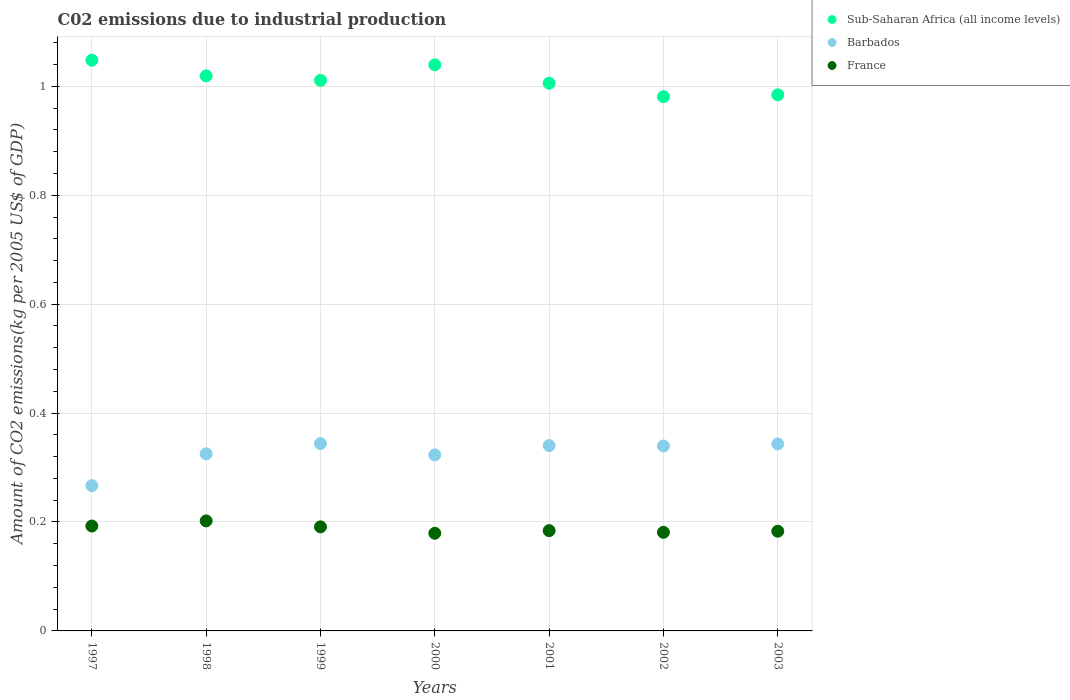What is the amount of CO2 emitted due to industrial production in Sub-Saharan Africa (all income levels) in 1997?
Make the answer very short. 1.05. Across all years, what is the maximum amount of CO2 emitted due to industrial production in Barbados?
Make the answer very short. 0.34. Across all years, what is the minimum amount of CO2 emitted due to industrial production in France?
Provide a succinct answer. 0.18. What is the total amount of CO2 emitted due to industrial production in Barbados in the graph?
Ensure brevity in your answer.  2.28. What is the difference between the amount of CO2 emitted due to industrial production in France in 2000 and that in 2003?
Make the answer very short. -0. What is the difference between the amount of CO2 emitted due to industrial production in Barbados in 1998 and the amount of CO2 emitted due to industrial production in Sub-Saharan Africa (all income levels) in 2000?
Provide a short and direct response. -0.71. What is the average amount of CO2 emitted due to industrial production in Sub-Saharan Africa (all income levels) per year?
Offer a terse response. 1.01. In the year 1999, what is the difference between the amount of CO2 emitted due to industrial production in Barbados and amount of CO2 emitted due to industrial production in Sub-Saharan Africa (all income levels)?
Give a very brief answer. -0.67. What is the ratio of the amount of CO2 emitted due to industrial production in Sub-Saharan Africa (all income levels) in 2000 to that in 2002?
Offer a very short reply. 1.06. What is the difference between the highest and the second highest amount of CO2 emitted due to industrial production in France?
Provide a succinct answer. 0.01. What is the difference between the highest and the lowest amount of CO2 emitted due to industrial production in France?
Give a very brief answer. 0.02. Is the amount of CO2 emitted due to industrial production in Barbados strictly greater than the amount of CO2 emitted due to industrial production in Sub-Saharan Africa (all income levels) over the years?
Your answer should be very brief. No. How many dotlines are there?
Offer a terse response. 3. How many years are there in the graph?
Keep it short and to the point. 7. Are the values on the major ticks of Y-axis written in scientific E-notation?
Provide a succinct answer. No. Does the graph contain grids?
Offer a very short reply. Yes. How many legend labels are there?
Make the answer very short. 3. How are the legend labels stacked?
Provide a short and direct response. Vertical. What is the title of the graph?
Offer a terse response. C02 emissions due to industrial production. Does "Namibia" appear as one of the legend labels in the graph?
Provide a short and direct response. No. What is the label or title of the Y-axis?
Your response must be concise. Amount of CO2 emissions(kg per 2005 US$ of GDP). What is the Amount of CO2 emissions(kg per 2005 US$ of GDP) in Sub-Saharan Africa (all income levels) in 1997?
Offer a terse response. 1.05. What is the Amount of CO2 emissions(kg per 2005 US$ of GDP) in Barbados in 1997?
Provide a short and direct response. 0.27. What is the Amount of CO2 emissions(kg per 2005 US$ of GDP) of France in 1997?
Provide a succinct answer. 0.19. What is the Amount of CO2 emissions(kg per 2005 US$ of GDP) of Sub-Saharan Africa (all income levels) in 1998?
Your response must be concise. 1.02. What is the Amount of CO2 emissions(kg per 2005 US$ of GDP) in Barbados in 1998?
Offer a terse response. 0.33. What is the Amount of CO2 emissions(kg per 2005 US$ of GDP) in France in 1998?
Offer a terse response. 0.2. What is the Amount of CO2 emissions(kg per 2005 US$ of GDP) of Sub-Saharan Africa (all income levels) in 1999?
Give a very brief answer. 1.01. What is the Amount of CO2 emissions(kg per 2005 US$ of GDP) of Barbados in 1999?
Your answer should be very brief. 0.34. What is the Amount of CO2 emissions(kg per 2005 US$ of GDP) of France in 1999?
Provide a short and direct response. 0.19. What is the Amount of CO2 emissions(kg per 2005 US$ of GDP) in Sub-Saharan Africa (all income levels) in 2000?
Give a very brief answer. 1.04. What is the Amount of CO2 emissions(kg per 2005 US$ of GDP) in Barbados in 2000?
Offer a terse response. 0.32. What is the Amount of CO2 emissions(kg per 2005 US$ of GDP) of France in 2000?
Ensure brevity in your answer.  0.18. What is the Amount of CO2 emissions(kg per 2005 US$ of GDP) of Sub-Saharan Africa (all income levels) in 2001?
Offer a terse response. 1.01. What is the Amount of CO2 emissions(kg per 2005 US$ of GDP) of Barbados in 2001?
Give a very brief answer. 0.34. What is the Amount of CO2 emissions(kg per 2005 US$ of GDP) of France in 2001?
Ensure brevity in your answer.  0.18. What is the Amount of CO2 emissions(kg per 2005 US$ of GDP) of Sub-Saharan Africa (all income levels) in 2002?
Your answer should be compact. 0.98. What is the Amount of CO2 emissions(kg per 2005 US$ of GDP) in Barbados in 2002?
Offer a terse response. 0.34. What is the Amount of CO2 emissions(kg per 2005 US$ of GDP) of France in 2002?
Offer a terse response. 0.18. What is the Amount of CO2 emissions(kg per 2005 US$ of GDP) of Sub-Saharan Africa (all income levels) in 2003?
Offer a terse response. 0.98. What is the Amount of CO2 emissions(kg per 2005 US$ of GDP) in Barbados in 2003?
Your answer should be very brief. 0.34. What is the Amount of CO2 emissions(kg per 2005 US$ of GDP) in France in 2003?
Provide a short and direct response. 0.18. Across all years, what is the maximum Amount of CO2 emissions(kg per 2005 US$ of GDP) of Sub-Saharan Africa (all income levels)?
Offer a terse response. 1.05. Across all years, what is the maximum Amount of CO2 emissions(kg per 2005 US$ of GDP) of Barbados?
Provide a short and direct response. 0.34. Across all years, what is the maximum Amount of CO2 emissions(kg per 2005 US$ of GDP) in France?
Provide a short and direct response. 0.2. Across all years, what is the minimum Amount of CO2 emissions(kg per 2005 US$ of GDP) in Sub-Saharan Africa (all income levels)?
Offer a terse response. 0.98. Across all years, what is the minimum Amount of CO2 emissions(kg per 2005 US$ of GDP) in Barbados?
Keep it short and to the point. 0.27. Across all years, what is the minimum Amount of CO2 emissions(kg per 2005 US$ of GDP) in France?
Offer a terse response. 0.18. What is the total Amount of CO2 emissions(kg per 2005 US$ of GDP) in Sub-Saharan Africa (all income levels) in the graph?
Provide a succinct answer. 7.09. What is the total Amount of CO2 emissions(kg per 2005 US$ of GDP) of Barbados in the graph?
Your answer should be very brief. 2.28. What is the total Amount of CO2 emissions(kg per 2005 US$ of GDP) of France in the graph?
Your answer should be compact. 1.31. What is the difference between the Amount of CO2 emissions(kg per 2005 US$ of GDP) in Sub-Saharan Africa (all income levels) in 1997 and that in 1998?
Ensure brevity in your answer.  0.03. What is the difference between the Amount of CO2 emissions(kg per 2005 US$ of GDP) of Barbados in 1997 and that in 1998?
Provide a succinct answer. -0.06. What is the difference between the Amount of CO2 emissions(kg per 2005 US$ of GDP) in France in 1997 and that in 1998?
Give a very brief answer. -0.01. What is the difference between the Amount of CO2 emissions(kg per 2005 US$ of GDP) of Sub-Saharan Africa (all income levels) in 1997 and that in 1999?
Give a very brief answer. 0.04. What is the difference between the Amount of CO2 emissions(kg per 2005 US$ of GDP) in Barbados in 1997 and that in 1999?
Ensure brevity in your answer.  -0.08. What is the difference between the Amount of CO2 emissions(kg per 2005 US$ of GDP) in France in 1997 and that in 1999?
Make the answer very short. 0. What is the difference between the Amount of CO2 emissions(kg per 2005 US$ of GDP) in Sub-Saharan Africa (all income levels) in 1997 and that in 2000?
Offer a very short reply. 0.01. What is the difference between the Amount of CO2 emissions(kg per 2005 US$ of GDP) of Barbados in 1997 and that in 2000?
Keep it short and to the point. -0.06. What is the difference between the Amount of CO2 emissions(kg per 2005 US$ of GDP) of France in 1997 and that in 2000?
Provide a succinct answer. 0.01. What is the difference between the Amount of CO2 emissions(kg per 2005 US$ of GDP) in Sub-Saharan Africa (all income levels) in 1997 and that in 2001?
Offer a terse response. 0.04. What is the difference between the Amount of CO2 emissions(kg per 2005 US$ of GDP) in Barbados in 1997 and that in 2001?
Provide a short and direct response. -0.07. What is the difference between the Amount of CO2 emissions(kg per 2005 US$ of GDP) of France in 1997 and that in 2001?
Offer a very short reply. 0.01. What is the difference between the Amount of CO2 emissions(kg per 2005 US$ of GDP) of Sub-Saharan Africa (all income levels) in 1997 and that in 2002?
Your answer should be very brief. 0.07. What is the difference between the Amount of CO2 emissions(kg per 2005 US$ of GDP) in Barbados in 1997 and that in 2002?
Give a very brief answer. -0.07. What is the difference between the Amount of CO2 emissions(kg per 2005 US$ of GDP) in France in 1997 and that in 2002?
Offer a terse response. 0.01. What is the difference between the Amount of CO2 emissions(kg per 2005 US$ of GDP) in Sub-Saharan Africa (all income levels) in 1997 and that in 2003?
Give a very brief answer. 0.06. What is the difference between the Amount of CO2 emissions(kg per 2005 US$ of GDP) of Barbados in 1997 and that in 2003?
Your answer should be compact. -0.08. What is the difference between the Amount of CO2 emissions(kg per 2005 US$ of GDP) of France in 1997 and that in 2003?
Your answer should be compact. 0.01. What is the difference between the Amount of CO2 emissions(kg per 2005 US$ of GDP) of Sub-Saharan Africa (all income levels) in 1998 and that in 1999?
Give a very brief answer. 0.01. What is the difference between the Amount of CO2 emissions(kg per 2005 US$ of GDP) in Barbados in 1998 and that in 1999?
Your response must be concise. -0.02. What is the difference between the Amount of CO2 emissions(kg per 2005 US$ of GDP) of France in 1998 and that in 1999?
Offer a very short reply. 0.01. What is the difference between the Amount of CO2 emissions(kg per 2005 US$ of GDP) in Sub-Saharan Africa (all income levels) in 1998 and that in 2000?
Provide a short and direct response. -0.02. What is the difference between the Amount of CO2 emissions(kg per 2005 US$ of GDP) in Barbados in 1998 and that in 2000?
Offer a terse response. 0. What is the difference between the Amount of CO2 emissions(kg per 2005 US$ of GDP) of France in 1998 and that in 2000?
Keep it short and to the point. 0.02. What is the difference between the Amount of CO2 emissions(kg per 2005 US$ of GDP) in Sub-Saharan Africa (all income levels) in 1998 and that in 2001?
Offer a very short reply. 0.01. What is the difference between the Amount of CO2 emissions(kg per 2005 US$ of GDP) in Barbados in 1998 and that in 2001?
Give a very brief answer. -0.02. What is the difference between the Amount of CO2 emissions(kg per 2005 US$ of GDP) in France in 1998 and that in 2001?
Your answer should be very brief. 0.02. What is the difference between the Amount of CO2 emissions(kg per 2005 US$ of GDP) in Sub-Saharan Africa (all income levels) in 1998 and that in 2002?
Offer a terse response. 0.04. What is the difference between the Amount of CO2 emissions(kg per 2005 US$ of GDP) in Barbados in 1998 and that in 2002?
Ensure brevity in your answer.  -0.01. What is the difference between the Amount of CO2 emissions(kg per 2005 US$ of GDP) in France in 1998 and that in 2002?
Provide a short and direct response. 0.02. What is the difference between the Amount of CO2 emissions(kg per 2005 US$ of GDP) of Sub-Saharan Africa (all income levels) in 1998 and that in 2003?
Ensure brevity in your answer.  0.03. What is the difference between the Amount of CO2 emissions(kg per 2005 US$ of GDP) of Barbados in 1998 and that in 2003?
Give a very brief answer. -0.02. What is the difference between the Amount of CO2 emissions(kg per 2005 US$ of GDP) in France in 1998 and that in 2003?
Give a very brief answer. 0.02. What is the difference between the Amount of CO2 emissions(kg per 2005 US$ of GDP) of Sub-Saharan Africa (all income levels) in 1999 and that in 2000?
Ensure brevity in your answer.  -0.03. What is the difference between the Amount of CO2 emissions(kg per 2005 US$ of GDP) in Barbados in 1999 and that in 2000?
Your answer should be very brief. 0.02. What is the difference between the Amount of CO2 emissions(kg per 2005 US$ of GDP) of France in 1999 and that in 2000?
Make the answer very short. 0.01. What is the difference between the Amount of CO2 emissions(kg per 2005 US$ of GDP) in Sub-Saharan Africa (all income levels) in 1999 and that in 2001?
Provide a short and direct response. 0.01. What is the difference between the Amount of CO2 emissions(kg per 2005 US$ of GDP) of Barbados in 1999 and that in 2001?
Keep it short and to the point. 0. What is the difference between the Amount of CO2 emissions(kg per 2005 US$ of GDP) of France in 1999 and that in 2001?
Offer a terse response. 0.01. What is the difference between the Amount of CO2 emissions(kg per 2005 US$ of GDP) in Sub-Saharan Africa (all income levels) in 1999 and that in 2002?
Provide a short and direct response. 0.03. What is the difference between the Amount of CO2 emissions(kg per 2005 US$ of GDP) in Barbados in 1999 and that in 2002?
Provide a short and direct response. 0. What is the difference between the Amount of CO2 emissions(kg per 2005 US$ of GDP) in Sub-Saharan Africa (all income levels) in 1999 and that in 2003?
Your answer should be compact. 0.03. What is the difference between the Amount of CO2 emissions(kg per 2005 US$ of GDP) in Barbados in 1999 and that in 2003?
Keep it short and to the point. 0. What is the difference between the Amount of CO2 emissions(kg per 2005 US$ of GDP) in France in 1999 and that in 2003?
Your answer should be very brief. 0.01. What is the difference between the Amount of CO2 emissions(kg per 2005 US$ of GDP) in Sub-Saharan Africa (all income levels) in 2000 and that in 2001?
Ensure brevity in your answer.  0.03. What is the difference between the Amount of CO2 emissions(kg per 2005 US$ of GDP) of Barbados in 2000 and that in 2001?
Your response must be concise. -0.02. What is the difference between the Amount of CO2 emissions(kg per 2005 US$ of GDP) of France in 2000 and that in 2001?
Give a very brief answer. -0. What is the difference between the Amount of CO2 emissions(kg per 2005 US$ of GDP) in Sub-Saharan Africa (all income levels) in 2000 and that in 2002?
Your response must be concise. 0.06. What is the difference between the Amount of CO2 emissions(kg per 2005 US$ of GDP) of Barbados in 2000 and that in 2002?
Provide a short and direct response. -0.02. What is the difference between the Amount of CO2 emissions(kg per 2005 US$ of GDP) of France in 2000 and that in 2002?
Your answer should be very brief. -0. What is the difference between the Amount of CO2 emissions(kg per 2005 US$ of GDP) in Sub-Saharan Africa (all income levels) in 2000 and that in 2003?
Make the answer very short. 0.06. What is the difference between the Amount of CO2 emissions(kg per 2005 US$ of GDP) of Barbados in 2000 and that in 2003?
Your answer should be very brief. -0.02. What is the difference between the Amount of CO2 emissions(kg per 2005 US$ of GDP) of France in 2000 and that in 2003?
Provide a short and direct response. -0. What is the difference between the Amount of CO2 emissions(kg per 2005 US$ of GDP) of Sub-Saharan Africa (all income levels) in 2001 and that in 2002?
Offer a very short reply. 0.02. What is the difference between the Amount of CO2 emissions(kg per 2005 US$ of GDP) in Barbados in 2001 and that in 2002?
Your response must be concise. 0. What is the difference between the Amount of CO2 emissions(kg per 2005 US$ of GDP) in France in 2001 and that in 2002?
Offer a very short reply. 0. What is the difference between the Amount of CO2 emissions(kg per 2005 US$ of GDP) in Sub-Saharan Africa (all income levels) in 2001 and that in 2003?
Provide a short and direct response. 0.02. What is the difference between the Amount of CO2 emissions(kg per 2005 US$ of GDP) in Barbados in 2001 and that in 2003?
Provide a succinct answer. -0. What is the difference between the Amount of CO2 emissions(kg per 2005 US$ of GDP) in France in 2001 and that in 2003?
Your response must be concise. 0. What is the difference between the Amount of CO2 emissions(kg per 2005 US$ of GDP) in Sub-Saharan Africa (all income levels) in 2002 and that in 2003?
Make the answer very short. -0. What is the difference between the Amount of CO2 emissions(kg per 2005 US$ of GDP) in Barbados in 2002 and that in 2003?
Your response must be concise. -0. What is the difference between the Amount of CO2 emissions(kg per 2005 US$ of GDP) of France in 2002 and that in 2003?
Provide a short and direct response. -0. What is the difference between the Amount of CO2 emissions(kg per 2005 US$ of GDP) in Sub-Saharan Africa (all income levels) in 1997 and the Amount of CO2 emissions(kg per 2005 US$ of GDP) in Barbados in 1998?
Your answer should be compact. 0.72. What is the difference between the Amount of CO2 emissions(kg per 2005 US$ of GDP) in Sub-Saharan Africa (all income levels) in 1997 and the Amount of CO2 emissions(kg per 2005 US$ of GDP) in France in 1998?
Ensure brevity in your answer.  0.85. What is the difference between the Amount of CO2 emissions(kg per 2005 US$ of GDP) in Barbados in 1997 and the Amount of CO2 emissions(kg per 2005 US$ of GDP) in France in 1998?
Provide a succinct answer. 0.06. What is the difference between the Amount of CO2 emissions(kg per 2005 US$ of GDP) in Sub-Saharan Africa (all income levels) in 1997 and the Amount of CO2 emissions(kg per 2005 US$ of GDP) in Barbados in 1999?
Give a very brief answer. 0.7. What is the difference between the Amount of CO2 emissions(kg per 2005 US$ of GDP) in Sub-Saharan Africa (all income levels) in 1997 and the Amount of CO2 emissions(kg per 2005 US$ of GDP) in France in 1999?
Your answer should be compact. 0.86. What is the difference between the Amount of CO2 emissions(kg per 2005 US$ of GDP) of Barbados in 1997 and the Amount of CO2 emissions(kg per 2005 US$ of GDP) of France in 1999?
Provide a short and direct response. 0.08. What is the difference between the Amount of CO2 emissions(kg per 2005 US$ of GDP) in Sub-Saharan Africa (all income levels) in 1997 and the Amount of CO2 emissions(kg per 2005 US$ of GDP) in Barbados in 2000?
Provide a short and direct response. 0.72. What is the difference between the Amount of CO2 emissions(kg per 2005 US$ of GDP) of Sub-Saharan Africa (all income levels) in 1997 and the Amount of CO2 emissions(kg per 2005 US$ of GDP) of France in 2000?
Offer a terse response. 0.87. What is the difference between the Amount of CO2 emissions(kg per 2005 US$ of GDP) of Barbados in 1997 and the Amount of CO2 emissions(kg per 2005 US$ of GDP) of France in 2000?
Provide a succinct answer. 0.09. What is the difference between the Amount of CO2 emissions(kg per 2005 US$ of GDP) in Sub-Saharan Africa (all income levels) in 1997 and the Amount of CO2 emissions(kg per 2005 US$ of GDP) in Barbados in 2001?
Provide a succinct answer. 0.71. What is the difference between the Amount of CO2 emissions(kg per 2005 US$ of GDP) of Sub-Saharan Africa (all income levels) in 1997 and the Amount of CO2 emissions(kg per 2005 US$ of GDP) of France in 2001?
Offer a terse response. 0.86. What is the difference between the Amount of CO2 emissions(kg per 2005 US$ of GDP) of Barbados in 1997 and the Amount of CO2 emissions(kg per 2005 US$ of GDP) of France in 2001?
Provide a short and direct response. 0.08. What is the difference between the Amount of CO2 emissions(kg per 2005 US$ of GDP) in Sub-Saharan Africa (all income levels) in 1997 and the Amount of CO2 emissions(kg per 2005 US$ of GDP) in Barbados in 2002?
Offer a terse response. 0.71. What is the difference between the Amount of CO2 emissions(kg per 2005 US$ of GDP) in Sub-Saharan Africa (all income levels) in 1997 and the Amount of CO2 emissions(kg per 2005 US$ of GDP) in France in 2002?
Your answer should be very brief. 0.87. What is the difference between the Amount of CO2 emissions(kg per 2005 US$ of GDP) in Barbados in 1997 and the Amount of CO2 emissions(kg per 2005 US$ of GDP) in France in 2002?
Your response must be concise. 0.09. What is the difference between the Amount of CO2 emissions(kg per 2005 US$ of GDP) in Sub-Saharan Africa (all income levels) in 1997 and the Amount of CO2 emissions(kg per 2005 US$ of GDP) in Barbados in 2003?
Provide a succinct answer. 0.7. What is the difference between the Amount of CO2 emissions(kg per 2005 US$ of GDP) in Sub-Saharan Africa (all income levels) in 1997 and the Amount of CO2 emissions(kg per 2005 US$ of GDP) in France in 2003?
Provide a succinct answer. 0.86. What is the difference between the Amount of CO2 emissions(kg per 2005 US$ of GDP) in Barbados in 1997 and the Amount of CO2 emissions(kg per 2005 US$ of GDP) in France in 2003?
Make the answer very short. 0.08. What is the difference between the Amount of CO2 emissions(kg per 2005 US$ of GDP) of Sub-Saharan Africa (all income levels) in 1998 and the Amount of CO2 emissions(kg per 2005 US$ of GDP) of Barbados in 1999?
Your answer should be compact. 0.68. What is the difference between the Amount of CO2 emissions(kg per 2005 US$ of GDP) of Sub-Saharan Africa (all income levels) in 1998 and the Amount of CO2 emissions(kg per 2005 US$ of GDP) of France in 1999?
Your answer should be very brief. 0.83. What is the difference between the Amount of CO2 emissions(kg per 2005 US$ of GDP) of Barbados in 1998 and the Amount of CO2 emissions(kg per 2005 US$ of GDP) of France in 1999?
Provide a succinct answer. 0.13. What is the difference between the Amount of CO2 emissions(kg per 2005 US$ of GDP) in Sub-Saharan Africa (all income levels) in 1998 and the Amount of CO2 emissions(kg per 2005 US$ of GDP) in Barbados in 2000?
Your answer should be compact. 0.7. What is the difference between the Amount of CO2 emissions(kg per 2005 US$ of GDP) of Sub-Saharan Africa (all income levels) in 1998 and the Amount of CO2 emissions(kg per 2005 US$ of GDP) of France in 2000?
Provide a succinct answer. 0.84. What is the difference between the Amount of CO2 emissions(kg per 2005 US$ of GDP) in Barbados in 1998 and the Amount of CO2 emissions(kg per 2005 US$ of GDP) in France in 2000?
Provide a succinct answer. 0.15. What is the difference between the Amount of CO2 emissions(kg per 2005 US$ of GDP) of Sub-Saharan Africa (all income levels) in 1998 and the Amount of CO2 emissions(kg per 2005 US$ of GDP) of Barbados in 2001?
Make the answer very short. 0.68. What is the difference between the Amount of CO2 emissions(kg per 2005 US$ of GDP) of Sub-Saharan Africa (all income levels) in 1998 and the Amount of CO2 emissions(kg per 2005 US$ of GDP) of France in 2001?
Your response must be concise. 0.83. What is the difference between the Amount of CO2 emissions(kg per 2005 US$ of GDP) of Barbados in 1998 and the Amount of CO2 emissions(kg per 2005 US$ of GDP) of France in 2001?
Your response must be concise. 0.14. What is the difference between the Amount of CO2 emissions(kg per 2005 US$ of GDP) of Sub-Saharan Africa (all income levels) in 1998 and the Amount of CO2 emissions(kg per 2005 US$ of GDP) of Barbados in 2002?
Your answer should be very brief. 0.68. What is the difference between the Amount of CO2 emissions(kg per 2005 US$ of GDP) of Sub-Saharan Africa (all income levels) in 1998 and the Amount of CO2 emissions(kg per 2005 US$ of GDP) of France in 2002?
Your answer should be compact. 0.84. What is the difference between the Amount of CO2 emissions(kg per 2005 US$ of GDP) in Barbados in 1998 and the Amount of CO2 emissions(kg per 2005 US$ of GDP) in France in 2002?
Provide a short and direct response. 0.14. What is the difference between the Amount of CO2 emissions(kg per 2005 US$ of GDP) in Sub-Saharan Africa (all income levels) in 1998 and the Amount of CO2 emissions(kg per 2005 US$ of GDP) in Barbados in 2003?
Provide a short and direct response. 0.68. What is the difference between the Amount of CO2 emissions(kg per 2005 US$ of GDP) in Sub-Saharan Africa (all income levels) in 1998 and the Amount of CO2 emissions(kg per 2005 US$ of GDP) in France in 2003?
Your answer should be compact. 0.84. What is the difference between the Amount of CO2 emissions(kg per 2005 US$ of GDP) in Barbados in 1998 and the Amount of CO2 emissions(kg per 2005 US$ of GDP) in France in 2003?
Provide a succinct answer. 0.14. What is the difference between the Amount of CO2 emissions(kg per 2005 US$ of GDP) of Sub-Saharan Africa (all income levels) in 1999 and the Amount of CO2 emissions(kg per 2005 US$ of GDP) of Barbados in 2000?
Provide a succinct answer. 0.69. What is the difference between the Amount of CO2 emissions(kg per 2005 US$ of GDP) in Sub-Saharan Africa (all income levels) in 1999 and the Amount of CO2 emissions(kg per 2005 US$ of GDP) in France in 2000?
Offer a terse response. 0.83. What is the difference between the Amount of CO2 emissions(kg per 2005 US$ of GDP) in Barbados in 1999 and the Amount of CO2 emissions(kg per 2005 US$ of GDP) in France in 2000?
Provide a succinct answer. 0.16. What is the difference between the Amount of CO2 emissions(kg per 2005 US$ of GDP) in Sub-Saharan Africa (all income levels) in 1999 and the Amount of CO2 emissions(kg per 2005 US$ of GDP) in Barbados in 2001?
Your answer should be compact. 0.67. What is the difference between the Amount of CO2 emissions(kg per 2005 US$ of GDP) of Sub-Saharan Africa (all income levels) in 1999 and the Amount of CO2 emissions(kg per 2005 US$ of GDP) of France in 2001?
Give a very brief answer. 0.83. What is the difference between the Amount of CO2 emissions(kg per 2005 US$ of GDP) of Barbados in 1999 and the Amount of CO2 emissions(kg per 2005 US$ of GDP) of France in 2001?
Provide a short and direct response. 0.16. What is the difference between the Amount of CO2 emissions(kg per 2005 US$ of GDP) of Sub-Saharan Africa (all income levels) in 1999 and the Amount of CO2 emissions(kg per 2005 US$ of GDP) of Barbados in 2002?
Offer a terse response. 0.67. What is the difference between the Amount of CO2 emissions(kg per 2005 US$ of GDP) in Sub-Saharan Africa (all income levels) in 1999 and the Amount of CO2 emissions(kg per 2005 US$ of GDP) in France in 2002?
Keep it short and to the point. 0.83. What is the difference between the Amount of CO2 emissions(kg per 2005 US$ of GDP) in Barbados in 1999 and the Amount of CO2 emissions(kg per 2005 US$ of GDP) in France in 2002?
Keep it short and to the point. 0.16. What is the difference between the Amount of CO2 emissions(kg per 2005 US$ of GDP) in Sub-Saharan Africa (all income levels) in 1999 and the Amount of CO2 emissions(kg per 2005 US$ of GDP) in Barbados in 2003?
Give a very brief answer. 0.67. What is the difference between the Amount of CO2 emissions(kg per 2005 US$ of GDP) in Sub-Saharan Africa (all income levels) in 1999 and the Amount of CO2 emissions(kg per 2005 US$ of GDP) in France in 2003?
Offer a terse response. 0.83. What is the difference between the Amount of CO2 emissions(kg per 2005 US$ of GDP) in Barbados in 1999 and the Amount of CO2 emissions(kg per 2005 US$ of GDP) in France in 2003?
Make the answer very short. 0.16. What is the difference between the Amount of CO2 emissions(kg per 2005 US$ of GDP) in Sub-Saharan Africa (all income levels) in 2000 and the Amount of CO2 emissions(kg per 2005 US$ of GDP) in Barbados in 2001?
Offer a terse response. 0.7. What is the difference between the Amount of CO2 emissions(kg per 2005 US$ of GDP) in Sub-Saharan Africa (all income levels) in 2000 and the Amount of CO2 emissions(kg per 2005 US$ of GDP) in France in 2001?
Provide a succinct answer. 0.86. What is the difference between the Amount of CO2 emissions(kg per 2005 US$ of GDP) in Barbados in 2000 and the Amount of CO2 emissions(kg per 2005 US$ of GDP) in France in 2001?
Offer a terse response. 0.14. What is the difference between the Amount of CO2 emissions(kg per 2005 US$ of GDP) in Sub-Saharan Africa (all income levels) in 2000 and the Amount of CO2 emissions(kg per 2005 US$ of GDP) in Barbados in 2002?
Ensure brevity in your answer.  0.7. What is the difference between the Amount of CO2 emissions(kg per 2005 US$ of GDP) of Sub-Saharan Africa (all income levels) in 2000 and the Amount of CO2 emissions(kg per 2005 US$ of GDP) of France in 2002?
Offer a very short reply. 0.86. What is the difference between the Amount of CO2 emissions(kg per 2005 US$ of GDP) of Barbados in 2000 and the Amount of CO2 emissions(kg per 2005 US$ of GDP) of France in 2002?
Make the answer very short. 0.14. What is the difference between the Amount of CO2 emissions(kg per 2005 US$ of GDP) in Sub-Saharan Africa (all income levels) in 2000 and the Amount of CO2 emissions(kg per 2005 US$ of GDP) in Barbados in 2003?
Ensure brevity in your answer.  0.7. What is the difference between the Amount of CO2 emissions(kg per 2005 US$ of GDP) of Sub-Saharan Africa (all income levels) in 2000 and the Amount of CO2 emissions(kg per 2005 US$ of GDP) of France in 2003?
Your response must be concise. 0.86. What is the difference between the Amount of CO2 emissions(kg per 2005 US$ of GDP) of Barbados in 2000 and the Amount of CO2 emissions(kg per 2005 US$ of GDP) of France in 2003?
Ensure brevity in your answer.  0.14. What is the difference between the Amount of CO2 emissions(kg per 2005 US$ of GDP) of Sub-Saharan Africa (all income levels) in 2001 and the Amount of CO2 emissions(kg per 2005 US$ of GDP) of Barbados in 2002?
Your answer should be very brief. 0.67. What is the difference between the Amount of CO2 emissions(kg per 2005 US$ of GDP) of Sub-Saharan Africa (all income levels) in 2001 and the Amount of CO2 emissions(kg per 2005 US$ of GDP) of France in 2002?
Provide a succinct answer. 0.82. What is the difference between the Amount of CO2 emissions(kg per 2005 US$ of GDP) of Barbados in 2001 and the Amount of CO2 emissions(kg per 2005 US$ of GDP) of France in 2002?
Ensure brevity in your answer.  0.16. What is the difference between the Amount of CO2 emissions(kg per 2005 US$ of GDP) of Sub-Saharan Africa (all income levels) in 2001 and the Amount of CO2 emissions(kg per 2005 US$ of GDP) of Barbados in 2003?
Your answer should be very brief. 0.66. What is the difference between the Amount of CO2 emissions(kg per 2005 US$ of GDP) in Sub-Saharan Africa (all income levels) in 2001 and the Amount of CO2 emissions(kg per 2005 US$ of GDP) in France in 2003?
Offer a terse response. 0.82. What is the difference between the Amount of CO2 emissions(kg per 2005 US$ of GDP) of Barbados in 2001 and the Amount of CO2 emissions(kg per 2005 US$ of GDP) of France in 2003?
Your answer should be compact. 0.16. What is the difference between the Amount of CO2 emissions(kg per 2005 US$ of GDP) of Sub-Saharan Africa (all income levels) in 2002 and the Amount of CO2 emissions(kg per 2005 US$ of GDP) of Barbados in 2003?
Offer a terse response. 0.64. What is the difference between the Amount of CO2 emissions(kg per 2005 US$ of GDP) in Sub-Saharan Africa (all income levels) in 2002 and the Amount of CO2 emissions(kg per 2005 US$ of GDP) in France in 2003?
Keep it short and to the point. 0.8. What is the difference between the Amount of CO2 emissions(kg per 2005 US$ of GDP) of Barbados in 2002 and the Amount of CO2 emissions(kg per 2005 US$ of GDP) of France in 2003?
Your response must be concise. 0.16. What is the average Amount of CO2 emissions(kg per 2005 US$ of GDP) in Sub-Saharan Africa (all income levels) per year?
Ensure brevity in your answer.  1.01. What is the average Amount of CO2 emissions(kg per 2005 US$ of GDP) of Barbados per year?
Give a very brief answer. 0.33. What is the average Amount of CO2 emissions(kg per 2005 US$ of GDP) of France per year?
Ensure brevity in your answer.  0.19. In the year 1997, what is the difference between the Amount of CO2 emissions(kg per 2005 US$ of GDP) in Sub-Saharan Africa (all income levels) and Amount of CO2 emissions(kg per 2005 US$ of GDP) in Barbados?
Provide a succinct answer. 0.78. In the year 1997, what is the difference between the Amount of CO2 emissions(kg per 2005 US$ of GDP) in Sub-Saharan Africa (all income levels) and Amount of CO2 emissions(kg per 2005 US$ of GDP) in France?
Keep it short and to the point. 0.86. In the year 1997, what is the difference between the Amount of CO2 emissions(kg per 2005 US$ of GDP) in Barbados and Amount of CO2 emissions(kg per 2005 US$ of GDP) in France?
Offer a terse response. 0.07. In the year 1998, what is the difference between the Amount of CO2 emissions(kg per 2005 US$ of GDP) in Sub-Saharan Africa (all income levels) and Amount of CO2 emissions(kg per 2005 US$ of GDP) in Barbados?
Give a very brief answer. 0.69. In the year 1998, what is the difference between the Amount of CO2 emissions(kg per 2005 US$ of GDP) of Sub-Saharan Africa (all income levels) and Amount of CO2 emissions(kg per 2005 US$ of GDP) of France?
Your answer should be very brief. 0.82. In the year 1998, what is the difference between the Amount of CO2 emissions(kg per 2005 US$ of GDP) of Barbados and Amount of CO2 emissions(kg per 2005 US$ of GDP) of France?
Make the answer very short. 0.12. In the year 1999, what is the difference between the Amount of CO2 emissions(kg per 2005 US$ of GDP) in Sub-Saharan Africa (all income levels) and Amount of CO2 emissions(kg per 2005 US$ of GDP) in Barbados?
Ensure brevity in your answer.  0.67. In the year 1999, what is the difference between the Amount of CO2 emissions(kg per 2005 US$ of GDP) of Sub-Saharan Africa (all income levels) and Amount of CO2 emissions(kg per 2005 US$ of GDP) of France?
Provide a succinct answer. 0.82. In the year 1999, what is the difference between the Amount of CO2 emissions(kg per 2005 US$ of GDP) of Barbados and Amount of CO2 emissions(kg per 2005 US$ of GDP) of France?
Your answer should be very brief. 0.15. In the year 2000, what is the difference between the Amount of CO2 emissions(kg per 2005 US$ of GDP) in Sub-Saharan Africa (all income levels) and Amount of CO2 emissions(kg per 2005 US$ of GDP) in Barbados?
Keep it short and to the point. 0.72. In the year 2000, what is the difference between the Amount of CO2 emissions(kg per 2005 US$ of GDP) in Sub-Saharan Africa (all income levels) and Amount of CO2 emissions(kg per 2005 US$ of GDP) in France?
Ensure brevity in your answer.  0.86. In the year 2000, what is the difference between the Amount of CO2 emissions(kg per 2005 US$ of GDP) in Barbados and Amount of CO2 emissions(kg per 2005 US$ of GDP) in France?
Offer a terse response. 0.14. In the year 2001, what is the difference between the Amount of CO2 emissions(kg per 2005 US$ of GDP) in Sub-Saharan Africa (all income levels) and Amount of CO2 emissions(kg per 2005 US$ of GDP) in Barbados?
Keep it short and to the point. 0.67. In the year 2001, what is the difference between the Amount of CO2 emissions(kg per 2005 US$ of GDP) of Sub-Saharan Africa (all income levels) and Amount of CO2 emissions(kg per 2005 US$ of GDP) of France?
Offer a terse response. 0.82. In the year 2001, what is the difference between the Amount of CO2 emissions(kg per 2005 US$ of GDP) in Barbados and Amount of CO2 emissions(kg per 2005 US$ of GDP) in France?
Give a very brief answer. 0.16. In the year 2002, what is the difference between the Amount of CO2 emissions(kg per 2005 US$ of GDP) in Sub-Saharan Africa (all income levels) and Amount of CO2 emissions(kg per 2005 US$ of GDP) in Barbados?
Keep it short and to the point. 0.64. In the year 2002, what is the difference between the Amount of CO2 emissions(kg per 2005 US$ of GDP) of Sub-Saharan Africa (all income levels) and Amount of CO2 emissions(kg per 2005 US$ of GDP) of France?
Offer a very short reply. 0.8. In the year 2002, what is the difference between the Amount of CO2 emissions(kg per 2005 US$ of GDP) in Barbados and Amount of CO2 emissions(kg per 2005 US$ of GDP) in France?
Offer a terse response. 0.16. In the year 2003, what is the difference between the Amount of CO2 emissions(kg per 2005 US$ of GDP) in Sub-Saharan Africa (all income levels) and Amount of CO2 emissions(kg per 2005 US$ of GDP) in Barbados?
Your answer should be very brief. 0.64. In the year 2003, what is the difference between the Amount of CO2 emissions(kg per 2005 US$ of GDP) of Sub-Saharan Africa (all income levels) and Amount of CO2 emissions(kg per 2005 US$ of GDP) of France?
Keep it short and to the point. 0.8. In the year 2003, what is the difference between the Amount of CO2 emissions(kg per 2005 US$ of GDP) in Barbados and Amount of CO2 emissions(kg per 2005 US$ of GDP) in France?
Keep it short and to the point. 0.16. What is the ratio of the Amount of CO2 emissions(kg per 2005 US$ of GDP) of Sub-Saharan Africa (all income levels) in 1997 to that in 1998?
Your answer should be compact. 1.03. What is the ratio of the Amount of CO2 emissions(kg per 2005 US$ of GDP) of Barbados in 1997 to that in 1998?
Provide a succinct answer. 0.82. What is the ratio of the Amount of CO2 emissions(kg per 2005 US$ of GDP) of France in 1997 to that in 1998?
Make the answer very short. 0.95. What is the ratio of the Amount of CO2 emissions(kg per 2005 US$ of GDP) of Sub-Saharan Africa (all income levels) in 1997 to that in 1999?
Give a very brief answer. 1.04. What is the ratio of the Amount of CO2 emissions(kg per 2005 US$ of GDP) in Barbados in 1997 to that in 1999?
Offer a terse response. 0.78. What is the ratio of the Amount of CO2 emissions(kg per 2005 US$ of GDP) of France in 1997 to that in 1999?
Keep it short and to the point. 1.01. What is the ratio of the Amount of CO2 emissions(kg per 2005 US$ of GDP) of Sub-Saharan Africa (all income levels) in 1997 to that in 2000?
Provide a succinct answer. 1.01. What is the ratio of the Amount of CO2 emissions(kg per 2005 US$ of GDP) in Barbados in 1997 to that in 2000?
Your answer should be very brief. 0.83. What is the ratio of the Amount of CO2 emissions(kg per 2005 US$ of GDP) in France in 1997 to that in 2000?
Offer a terse response. 1.07. What is the ratio of the Amount of CO2 emissions(kg per 2005 US$ of GDP) in Sub-Saharan Africa (all income levels) in 1997 to that in 2001?
Make the answer very short. 1.04. What is the ratio of the Amount of CO2 emissions(kg per 2005 US$ of GDP) in Barbados in 1997 to that in 2001?
Offer a very short reply. 0.78. What is the ratio of the Amount of CO2 emissions(kg per 2005 US$ of GDP) in France in 1997 to that in 2001?
Offer a very short reply. 1.05. What is the ratio of the Amount of CO2 emissions(kg per 2005 US$ of GDP) in Sub-Saharan Africa (all income levels) in 1997 to that in 2002?
Offer a terse response. 1.07. What is the ratio of the Amount of CO2 emissions(kg per 2005 US$ of GDP) in Barbados in 1997 to that in 2002?
Make the answer very short. 0.79. What is the ratio of the Amount of CO2 emissions(kg per 2005 US$ of GDP) of France in 1997 to that in 2002?
Offer a terse response. 1.06. What is the ratio of the Amount of CO2 emissions(kg per 2005 US$ of GDP) in Sub-Saharan Africa (all income levels) in 1997 to that in 2003?
Your answer should be very brief. 1.06. What is the ratio of the Amount of CO2 emissions(kg per 2005 US$ of GDP) of Barbados in 1997 to that in 2003?
Offer a very short reply. 0.78. What is the ratio of the Amount of CO2 emissions(kg per 2005 US$ of GDP) of France in 1997 to that in 2003?
Ensure brevity in your answer.  1.05. What is the ratio of the Amount of CO2 emissions(kg per 2005 US$ of GDP) in Sub-Saharan Africa (all income levels) in 1998 to that in 1999?
Offer a very short reply. 1.01. What is the ratio of the Amount of CO2 emissions(kg per 2005 US$ of GDP) of Barbados in 1998 to that in 1999?
Provide a short and direct response. 0.95. What is the ratio of the Amount of CO2 emissions(kg per 2005 US$ of GDP) in France in 1998 to that in 1999?
Make the answer very short. 1.06. What is the ratio of the Amount of CO2 emissions(kg per 2005 US$ of GDP) in Sub-Saharan Africa (all income levels) in 1998 to that in 2000?
Provide a short and direct response. 0.98. What is the ratio of the Amount of CO2 emissions(kg per 2005 US$ of GDP) in France in 1998 to that in 2000?
Your response must be concise. 1.13. What is the ratio of the Amount of CO2 emissions(kg per 2005 US$ of GDP) of Sub-Saharan Africa (all income levels) in 1998 to that in 2001?
Your answer should be compact. 1.01. What is the ratio of the Amount of CO2 emissions(kg per 2005 US$ of GDP) of Barbados in 1998 to that in 2001?
Provide a succinct answer. 0.96. What is the ratio of the Amount of CO2 emissions(kg per 2005 US$ of GDP) in France in 1998 to that in 2001?
Make the answer very short. 1.1. What is the ratio of the Amount of CO2 emissions(kg per 2005 US$ of GDP) in Sub-Saharan Africa (all income levels) in 1998 to that in 2002?
Offer a terse response. 1.04. What is the ratio of the Amount of CO2 emissions(kg per 2005 US$ of GDP) of Barbados in 1998 to that in 2002?
Your response must be concise. 0.96. What is the ratio of the Amount of CO2 emissions(kg per 2005 US$ of GDP) of France in 1998 to that in 2002?
Give a very brief answer. 1.12. What is the ratio of the Amount of CO2 emissions(kg per 2005 US$ of GDP) of Sub-Saharan Africa (all income levels) in 1998 to that in 2003?
Make the answer very short. 1.04. What is the ratio of the Amount of CO2 emissions(kg per 2005 US$ of GDP) in Barbados in 1998 to that in 2003?
Ensure brevity in your answer.  0.95. What is the ratio of the Amount of CO2 emissions(kg per 2005 US$ of GDP) in France in 1998 to that in 2003?
Provide a succinct answer. 1.1. What is the ratio of the Amount of CO2 emissions(kg per 2005 US$ of GDP) in Sub-Saharan Africa (all income levels) in 1999 to that in 2000?
Your answer should be very brief. 0.97. What is the ratio of the Amount of CO2 emissions(kg per 2005 US$ of GDP) in Barbados in 1999 to that in 2000?
Offer a terse response. 1.06. What is the ratio of the Amount of CO2 emissions(kg per 2005 US$ of GDP) of France in 1999 to that in 2000?
Provide a succinct answer. 1.07. What is the ratio of the Amount of CO2 emissions(kg per 2005 US$ of GDP) in Sub-Saharan Africa (all income levels) in 1999 to that in 2001?
Make the answer very short. 1.01. What is the ratio of the Amount of CO2 emissions(kg per 2005 US$ of GDP) in Barbados in 1999 to that in 2001?
Ensure brevity in your answer.  1.01. What is the ratio of the Amount of CO2 emissions(kg per 2005 US$ of GDP) of France in 1999 to that in 2001?
Ensure brevity in your answer.  1.04. What is the ratio of the Amount of CO2 emissions(kg per 2005 US$ of GDP) in Sub-Saharan Africa (all income levels) in 1999 to that in 2002?
Your answer should be very brief. 1.03. What is the ratio of the Amount of CO2 emissions(kg per 2005 US$ of GDP) in France in 1999 to that in 2002?
Provide a succinct answer. 1.06. What is the ratio of the Amount of CO2 emissions(kg per 2005 US$ of GDP) of Sub-Saharan Africa (all income levels) in 1999 to that in 2003?
Give a very brief answer. 1.03. What is the ratio of the Amount of CO2 emissions(kg per 2005 US$ of GDP) of Barbados in 1999 to that in 2003?
Offer a terse response. 1. What is the ratio of the Amount of CO2 emissions(kg per 2005 US$ of GDP) of France in 1999 to that in 2003?
Provide a succinct answer. 1.04. What is the ratio of the Amount of CO2 emissions(kg per 2005 US$ of GDP) in Sub-Saharan Africa (all income levels) in 2000 to that in 2001?
Offer a very short reply. 1.03. What is the ratio of the Amount of CO2 emissions(kg per 2005 US$ of GDP) in Barbados in 2000 to that in 2001?
Your answer should be compact. 0.95. What is the ratio of the Amount of CO2 emissions(kg per 2005 US$ of GDP) of France in 2000 to that in 2001?
Give a very brief answer. 0.97. What is the ratio of the Amount of CO2 emissions(kg per 2005 US$ of GDP) of Sub-Saharan Africa (all income levels) in 2000 to that in 2002?
Provide a succinct answer. 1.06. What is the ratio of the Amount of CO2 emissions(kg per 2005 US$ of GDP) of Barbados in 2000 to that in 2002?
Make the answer very short. 0.95. What is the ratio of the Amount of CO2 emissions(kg per 2005 US$ of GDP) in Sub-Saharan Africa (all income levels) in 2000 to that in 2003?
Your answer should be very brief. 1.06. What is the ratio of the Amount of CO2 emissions(kg per 2005 US$ of GDP) of Barbados in 2000 to that in 2003?
Your answer should be very brief. 0.94. What is the ratio of the Amount of CO2 emissions(kg per 2005 US$ of GDP) of France in 2000 to that in 2003?
Give a very brief answer. 0.98. What is the ratio of the Amount of CO2 emissions(kg per 2005 US$ of GDP) of Sub-Saharan Africa (all income levels) in 2001 to that in 2002?
Ensure brevity in your answer.  1.03. What is the ratio of the Amount of CO2 emissions(kg per 2005 US$ of GDP) in Barbados in 2001 to that in 2002?
Your answer should be compact. 1. What is the ratio of the Amount of CO2 emissions(kg per 2005 US$ of GDP) of France in 2001 to that in 2002?
Your answer should be very brief. 1.02. What is the ratio of the Amount of CO2 emissions(kg per 2005 US$ of GDP) in Sub-Saharan Africa (all income levels) in 2001 to that in 2003?
Give a very brief answer. 1.02. What is the ratio of the Amount of CO2 emissions(kg per 2005 US$ of GDP) in Barbados in 2001 to that in 2003?
Your response must be concise. 0.99. What is the ratio of the Amount of CO2 emissions(kg per 2005 US$ of GDP) in Barbados in 2002 to that in 2003?
Ensure brevity in your answer.  0.99. What is the ratio of the Amount of CO2 emissions(kg per 2005 US$ of GDP) in France in 2002 to that in 2003?
Give a very brief answer. 0.99. What is the difference between the highest and the second highest Amount of CO2 emissions(kg per 2005 US$ of GDP) in Sub-Saharan Africa (all income levels)?
Your answer should be compact. 0.01. What is the difference between the highest and the second highest Amount of CO2 emissions(kg per 2005 US$ of GDP) of Barbados?
Offer a terse response. 0. What is the difference between the highest and the second highest Amount of CO2 emissions(kg per 2005 US$ of GDP) of France?
Your response must be concise. 0.01. What is the difference between the highest and the lowest Amount of CO2 emissions(kg per 2005 US$ of GDP) of Sub-Saharan Africa (all income levels)?
Provide a succinct answer. 0.07. What is the difference between the highest and the lowest Amount of CO2 emissions(kg per 2005 US$ of GDP) in Barbados?
Your answer should be compact. 0.08. What is the difference between the highest and the lowest Amount of CO2 emissions(kg per 2005 US$ of GDP) in France?
Ensure brevity in your answer.  0.02. 